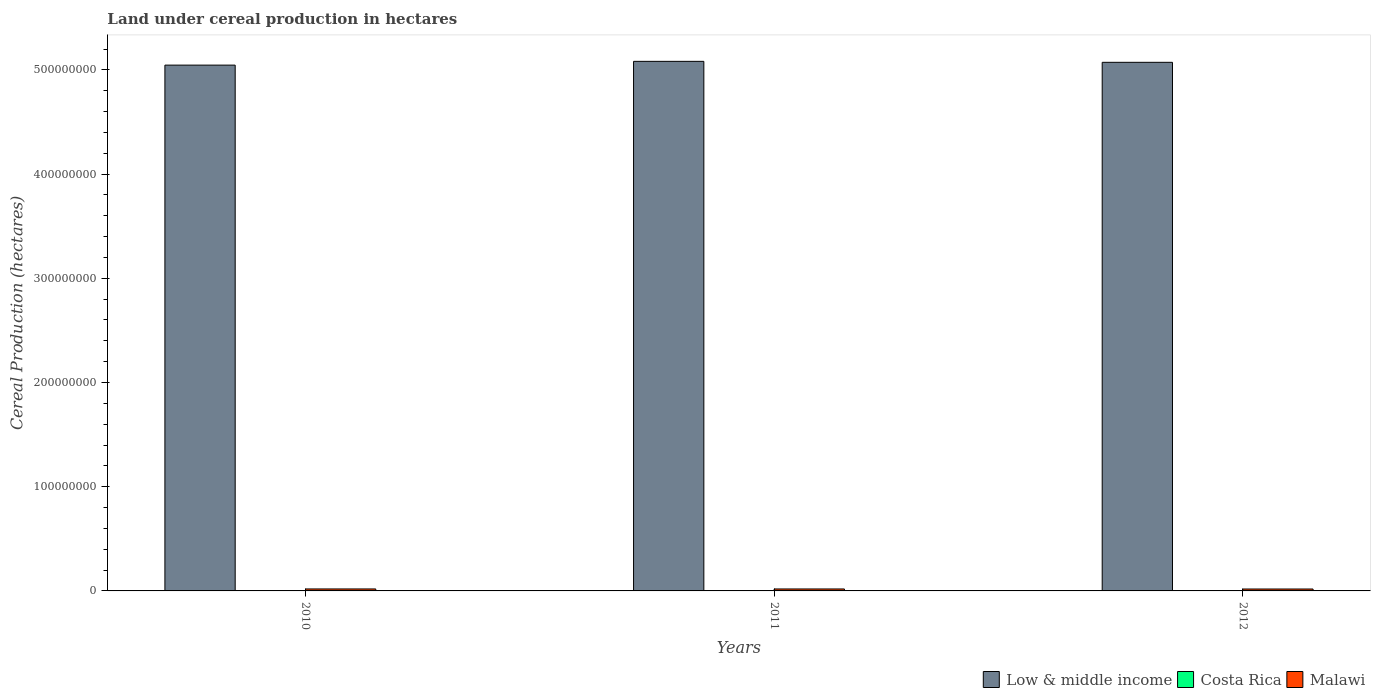How many different coloured bars are there?
Your answer should be very brief. 3. Are the number of bars per tick equal to the number of legend labels?
Your response must be concise. Yes. Are the number of bars on each tick of the X-axis equal?
Offer a very short reply. Yes. How many bars are there on the 1st tick from the left?
Your answer should be very brief. 3. What is the land under cereal production in Low & middle income in 2011?
Your response must be concise. 5.08e+08. Across all years, what is the maximum land under cereal production in Low & middle income?
Provide a short and direct response. 5.08e+08. Across all years, what is the minimum land under cereal production in Costa Rica?
Give a very brief answer. 7.60e+04. In which year was the land under cereal production in Low & middle income minimum?
Your response must be concise. 2010. What is the total land under cereal production in Low & middle income in the graph?
Provide a short and direct response. 1.52e+09. What is the difference between the land under cereal production in Costa Rica in 2010 and that in 2011?
Offer a very short reply. -1.33e+04. What is the difference between the land under cereal production in Malawi in 2011 and the land under cereal production in Low & middle income in 2012?
Give a very brief answer. -5.05e+08. What is the average land under cereal production in Low & middle income per year?
Ensure brevity in your answer.  5.07e+08. In the year 2011, what is the difference between the land under cereal production in Malawi and land under cereal production in Costa Rica?
Offer a terse response. 1.78e+06. In how many years, is the land under cereal production in Costa Rica greater than 380000000 hectares?
Give a very brief answer. 0. What is the ratio of the land under cereal production in Malawi in 2011 to that in 2012?
Ensure brevity in your answer.  1.02. What is the difference between the highest and the second highest land under cereal production in Malawi?
Ensure brevity in your answer.  1.92e+04. What is the difference between the highest and the lowest land under cereal production in Low & middle income?
Give a very brief answer. 3.62e+06. In how many years, is the land under cereal production in Low & middle income greater than the average land under cereal production in Low & middle income taken over all years?
Offer a terse response. 2. Is the sum of the land under cereal production in Malawi in 2011 and 2012 greater than the maximum land under cereal production in Costa Rica across all years?
Keep it short and to the point. Yes. What does the 2nd bar from the left in 2011 represents?
Give a very brief answer. Costa Rica. What does the 2nd bar from the right in 2010 represents?
Ensure brevity in your answer.  Costa Rica. Is it the case that in every year, the sum of the land under cereal production in Costa Rica and land under cereal production in Low & middle income is greater than the land under cereal production in Malawi?
Your answer should be very brief. Yes. Are all the bars in the graph horizontal?
Give a very brief answer. No. How many years are there in the graph?
Provide a short and direct response. 3. Are the values on the major ticks of Y-axis written in scientific E-notation?
Provide a short and direct response. No. Does the graph contain any zero values?
Give a very brief answer. No. How many legend labels are there?
Provide a short and direct response. 3. How are the legend labels stacked?
Offer a terse response. Horizontal. What is the title of the graph?
Provide a succinct answer. Land under cereal production in hectares. Does "Pacific island small states" appear as one of the legend labels in the graph?
Keep it short and to the point. No. What is the label or title of the Y-axis?
Ensure brevity in your answer.  Cereal Production (hectares). What is the Cereal Production (hectares) in Low & middle income in 2010?
Offer a very short reply. 5.05e+08. What is the Cereal Production (hectares) of Costa Rica in 2010?
Give a very brief answer. 7.60e+04. What is the Cereal Production (hectares) of Malawi in 2010?
Your response must be concise. 1.89e+06. What is the Cereal Production (hectares) of Low & middle income in 2011?
Provide a short and direct response. 5.08e+08. What is the Cereal Production (hectares) in Costa Rica in 2011?
Provide a succinct answer. 8.93e+04. What is the Cereal Production (hectares) of Malawi in 2011?
Offer a terse response. 1.87e+06. What is the Cereal Production (hectares) in Low & middle income in 2012?
Your answer should be very brief. 5.07e+08. What is the Cereal Production (hectares) of Costa Rica in 2012?
Offer a very short reply. 8.47e+04. What is the Cereal Production (hectares) of Malawi in 2012?
Ensure brevity in your answer.  1.84e+06. Across all years, what is the maximum Cereal Production (hectares) in Low & middle income?
Make the answer very short. 5.08e+08. Across all years, what is the maximum Cereal Production (hectares) of Costa Rica?
Make the answer very short. 8.93e+04. Across all years, what is the maximum Cereal Production (hectares) in Malawi?
Your response must be concise. 1.89e+06. Across all years, what is the minimum Cereal Production (hectares) in Low & middle income?
Provide a succinct answer. 5.05e+08. Across all years, what is the minimum Cereal Production (hectares) of Costa Rica?
Offer a terse response. 7.60e+04. Across all years, what is the minimum Cereal Production (hectares) of Malawi?
Make the answer very short. 1.84e+06. What is the total Cereal Production (hectares) of Low & middle income in the graph?
Offer a terse response. 1.52e+09. What is the total Cereal Production (hectares) in Costa Rica in the graph?
Keep it short and to the point. 2.50e+05. What is the total Cereal Production (hectares) of Malawi in the graph?
Give a very brief answer. 5.60e+06. What is the difference between the Cereal Production (hectares) in Low & middle income in 2010 and that in 2011?
Offer a very short reply. -3.62e+06. What is the difference between the Cereal Production (hectares) in Costa Rica in 2010 and that in 2011?
Your response must be concise. -1.33e+04. What is the difference between the Cereal Production (hectares) of Malawi in 2010 and that in 2011?
Give a very brief answer. 1.92e+04. What is the difference between the Cereal Production (hectares) in Low & middle income in 2010 and that in 2012?
Offer a terse response. -2.69e+06. What is the difference between the Cereal Production (hectares) in Costa Rica in 2010 and that in 2012?
Offer a terse response. -8692. What is the difference between the Cereal Production (hectares) in Malawi in 2010 and that in 2012?
Your answer should be compact. 5.69e+04. What is the difference between the Cereal Production (hectares) of Low & middle income in 2011 and that in 2012?
Provide a succinct answer. 9.31e+05. What is the difference between the Cereal Production (hectares) in Costa Rica in 2011 and that in 2012?
Make the answer very short. 4619. What is the difference between the Cereal Production (hectares) of Malawi in 2011 and that in 2012?
Keep it short and to the point. 3.77e+04. What is the difference between the Cereal Production (hectares) of Low & middle income in 2010 and the Cereal Production (hectares) of Costa Rica in 2011?
Keep it short and to the point. 5.04e+08. What is the difference between the Cereal Production (hectares) of Low & middle income in 2010 and the Cereal Production (hectares) of Malawi in 2011?
Your response must be concise. 5.03e+08. What is the difference between the Cereal Production (hectares) in Costa Rica in 2010 and the Cereal Production (hectares) in Malawi in 2011?
Offer a terse response. -1.80e+06. What is the difference between the Cereal Production (hectares) in Low & middle income in 2010 and the Cereal Production (hectares) in Costa Rica in 2012?
Your answer should be very brief. 5.04e+08. What is the difference between the Cereal Production (hectares) in Low & middle income in 2010 and the Cereal Production (hectares) in Malawi in 2012?
Your response must be concise. 5.03e+08. What is the difference between the Cereal Production (hectares) in Costa Rica in 2010 and the Cereal Production (hectares) in Malawi in 2012?
Ensure brevity in your answer.  -1.76e+06. What is the difference between the Cereal Production (hectares) in Low & middle income in 2011 and the Cereal Production (hectares) in Costa Rica in 2012?
Offer a terse response. 5.08e+08. What is the difference between the Cereal Production (hectares) of Low & middle income in 2011 and the Cereal Production (hectares) of Malawi in 2012?
Ensure brevity in your answer.  5.06e+08. What is the difference between the Cereal Production (hectares) in Costa Rica in 2011 and the Cereal Production (hectares) in Malawi in 2012?
Make the answer very short. -1.75e+06. What is the average Cereal Production (hectares) in Low & middle income per year?
Offer a very short reply. 5.07e+08. What is the average Cereal Production (hectares) in Costa Rica per year?
Your response must be concise. 8.33e+04. What is the average Cereal Production (hectares) in Malawi per year?
Ensure brevity in your answer.  1.87e+06. In the year 2010, what is the difference between the Cereal Production (hectares) in Low & middle income and Cereal Production (hectares) in Costa Rica?
Your response must be concise. 5.04e+08. In the year 2010, what is the difference between the Cereal Production (hectares) of Low & middle income and Cereal Production (hectares) of Malawi?
Offer a very short reply. 5.03e+08. In the year 2010, what is the difference between the Cereal Production (hectares) in Costa Rica and Cereal Production (hectares) in Malawi?
Offer a very short reply. -1.82e+06. In the year 2011, what is the difference between the Cereal Production (hectares) in Low & middle income and Cereal Production (hectares) in Costa Rica?
Keep it short and to the point. 5.08e+08. In the year 2011, what is the difference between the Cereal Production (hectares) in Low & middle income and Cereal Production (hectares) in Malawi?
Provide a short and direct response. 5.06e+08. In the year 2011, what is the difference between the Cereal Production (hectares) in Costa Rica and Cereal Production (hectares) in Malawi?
Provide a short and direct response. -1.78e+06. In the year 2012, what is the difference between the Cereal Production (hectares) of Low & middle income and Cereal Production (hectares) of Costa Rica?
Keep it short and to the point. 5.07e+08. In the year 2012, what is the difference between the Cereal Production (hectares) in Low & middle income and Cereal Production (hectares) in Malawi?
Offer a very short reply. 5.05e+08. In the year 2012, what is the difference between the Cereal Production (hectares) of Costa Rica and Cereal Production (hectares) of Malawi?
Provide a short and direct response. -1.75e+06. What is the ratio of the Cereal Production (hectares) of Low & middle income in 2010 to that in 2011?
Your answer should be very brief. 0.99. What is the ratio of the Cereal Production (hectares) in Costa Rica in 2010 to that in 2011?
Your answer should be compact. 0.85. What is the ratio of the Cereal Production (hectares) of Malawi in 2010 to that in 2011?
Make the answer very short. 1.01. What is the ratio of the Cereal Production (hectares) of Low & middle income in 2010 to that in 2012?
Offer a very short reply. 0.99. What is the ratio of the Cereal Production (hectares) of Costa Rica in 2010 to that in 2012?
Your answer should be compact. 0.9. What is the ratio of the Cereal Production (hectares) in Malawi in 2010 to that in 2012?
Offer a terse response. 1.03. What is the ratio of the Cereal Production (hectares) in Low & middle income in 2011 to that in 2012?
Your answer should be very brief. 1. What is the ratio of the Cereal Production (hectares) of Costa Rica in 2011 to that in 2012?
Provide a short and direct response. 1.05. What is the ratio of the Cereal Production (hectares) in Malawi in 2011 to that in 2012?
Your answer should be compact. 1.02. What is the difference between the highest and the second highest Cereal Production (hectares) of Low & middle income?
Your response must be concise. 9.31e+05. What is the difference between the highest and the second highest Cereal Production (hectares) of Costa Rica?
Make the answer very short. 4619. What is the difference between the highest and the second highest Cereal Production (hectares) of Malawi?
Your answer should be compact. 1.92e+04. What is the difference between the highest and the lowest Cereal Production (hectares) of Low & middle income?
Ensure brevity in your answer.  3.62e+06. What is the difference between the highest and the lowest Cereal Production (hectares) of Costa Rica?
Provide a short and direct response. 1.33e+04. What is the difference between the highest and the lowest Cereal Production (hectares) of Malawi?
Offer a terse response. 5.69e+04. 